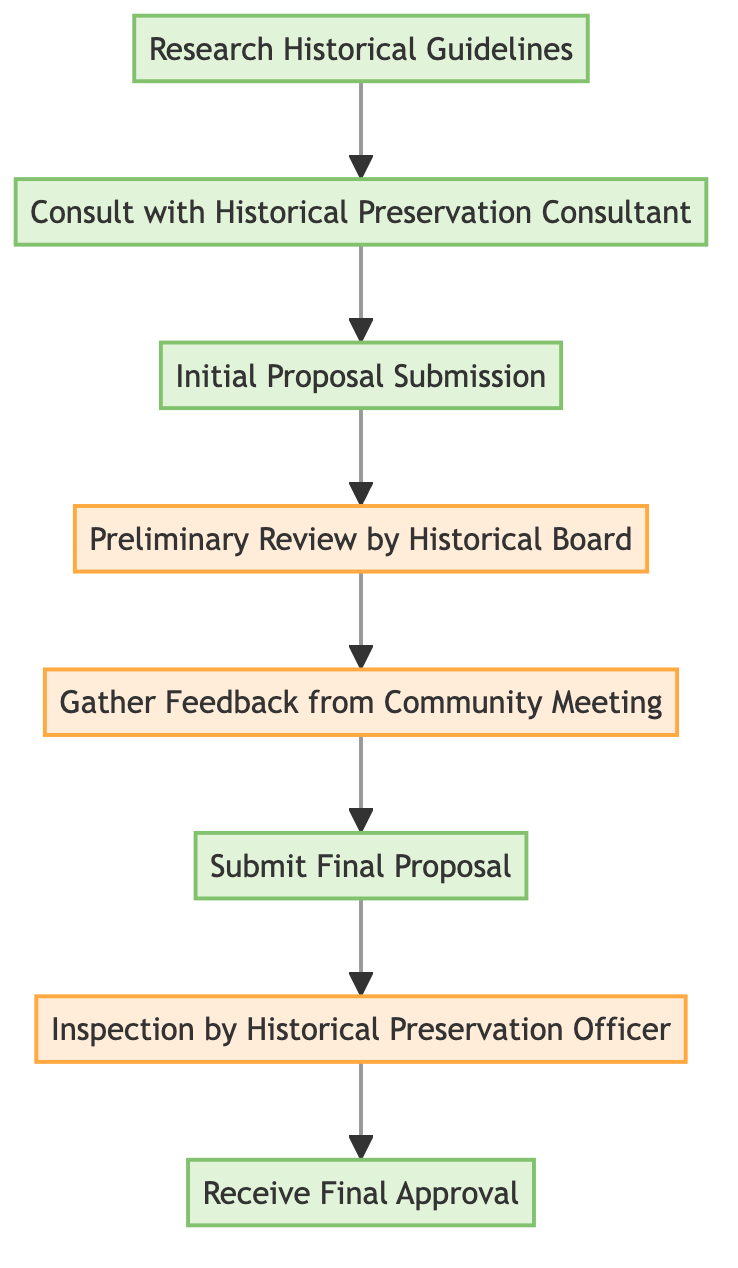What is the first step in the renovation approval process? The first step in the diagram is "Research Historical Guidelines". This is indicated as the starting point of the flowchart.
Answer: Research Historical Guidelines How many total nodes are in the flowchart? By counting each unique step in the flowchart, there are eight nodes total. The nodes are: Research Historical Guidelines, Consult with Historical Preservation Consultant, Initial Proposal Submission, Preliminary Review by Historical Board, Gather Feedback from Community Meeting, Submit Final Proposal, Inspection by Historical Preservation Officer, and Receive Final Approval.
Answer: Eight What step comes after the "Initial Proposal Submission"? The step that follows "Initial Proposal Submission" is "Preliminary Review by Historical Board". This is clear from the directional flow in the diagram.
Answer: Preliminary Review by Historical Board Which step requires gathering feedback from the community? The step named "Gather Feedback from Community Meeting" is specifically designated for obtaining input from community members. The wording in the node clearly indicates this purpose.
Answer: Gather Feedback from Community Meeting What step leads directly to the "Receive Final Approval"? The step leading directly to "Receive Final Approval" is "Inspection by Historical Preservation Officer". The directional flow indicates that after passing the inspection, final approval is granted.
Answer: Inspection by Historical Preservation Officer What type of review is conducted after the "Preliminary Review by Historical Board"? The review that follows the "Preliminary Review by Historical Board" is the "Gather Feedback from Community Meeting". This connection is made clear since the feedback gathering occurs right after the board’s preliminary review.
Answer: Gather Feedback from Community Meeting What step involves submitting a proposal after receiving community feedback? The step that involves submitting a proposal after reviewing community feedback is "Submit Final Proposal". This is indicated as the immediate next action following the gathering of feedback in the flowchart.
Answer: Submit Final Proposal What step reflects the supervision by a historical officer? The step that reflects supervision by a historical officer is "Inspection by Historical Preservation Officer". This is explicitly mentioned in the node and represents an important regulatory check in the process.
Answer: Inspection by Historical Preservation Officer 